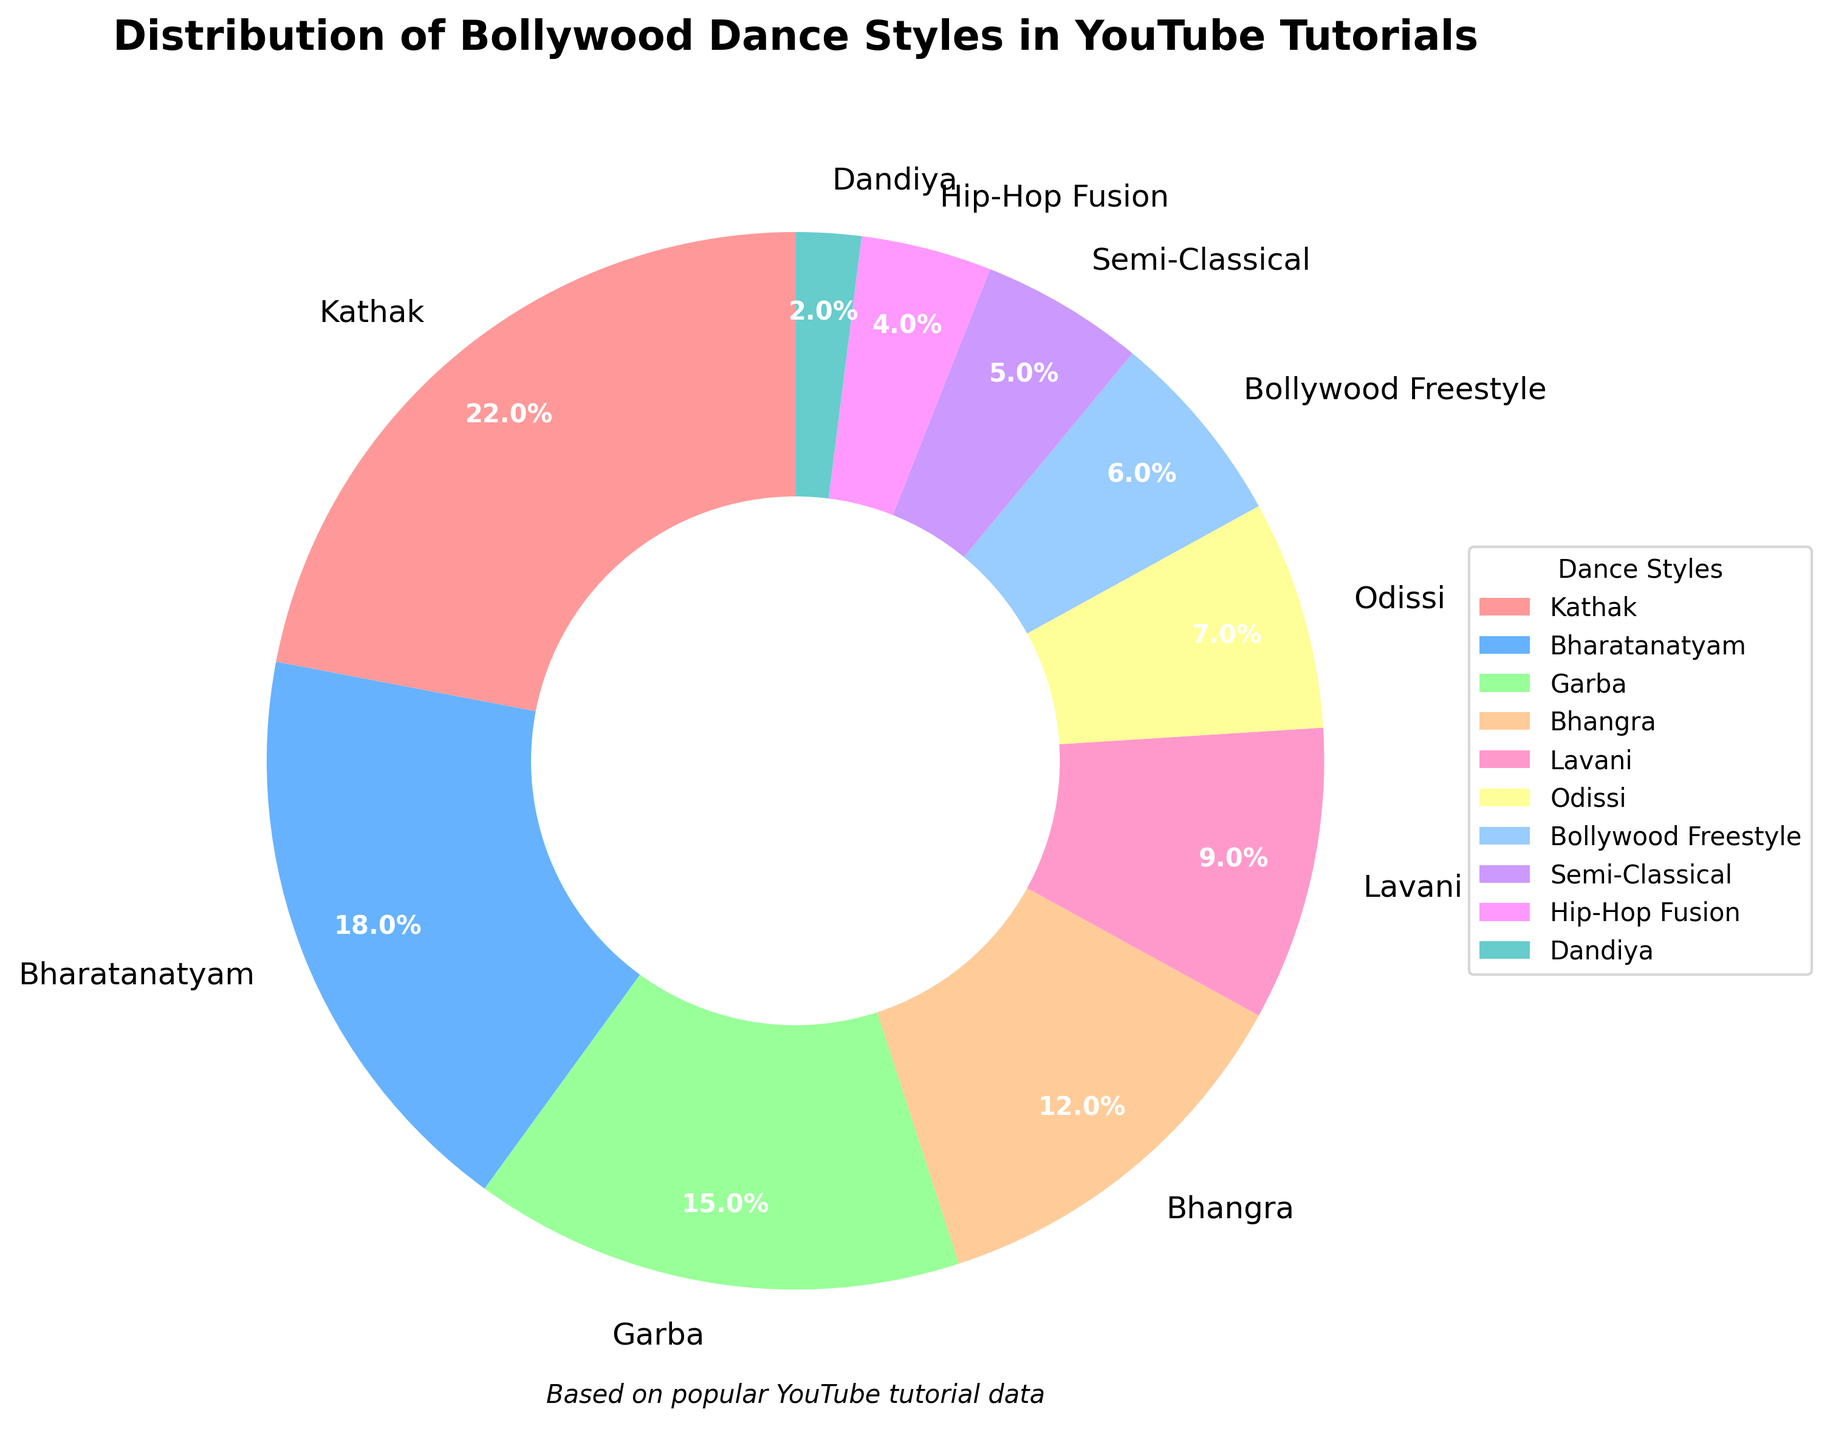What is the most popular dance style in the pie chart? The pie chart shows Kathak covering the largest segment. By looking at the visual size of the segments, Kathak is the largest.
Answer: Kathak Which dance styles contribute to exactly half of the distribution? We need to find styles summing up to 50%. Kathak (22%), Bharatanatyam (18%), and Garba (15%) exceed 50%. Checking smaller combinations, Kathak (22%), Bharatanatyam (18%), and Bhangra (12%) add up to 52%, so Kathak and Bharatanatyam alone sum to 40%. Adding Garba (15%), we exceed. Thus, no direct match of 50% is found for combinations.
Answer: None Which color represents the Lavani dance style in the pie chart? Each dance style is represented by a unique color. Lavani is colored similar to standard orange (second from bottom).
Answer: Orange How does the percentage of Bollywood Freestyle compare to Bhangra? Bollywood Freestyle is 6%, and Bhangra is 12%. Comparing these, Bhangra is larger.
Answer: Bhangra is larger What is the cumulative percentage of less popular styles (Hip-Hop Fusion, Semi-Classical, and Dandiya)? Sum the percentages of Hip-Hop Fusion (4%), Semi-Classical (5%), and Dandiya (2%). The sum is 4 + 5 + 2.
Answer: 11% What are the three least represented dance styles in the chart? Identify the smallest slices. Dandiya (2%), Hip-Hop Fusion (4%), and Semi-Classical (5%) are the smallest.
Answer: Dandiya, Hip-Hop Fusion, Semi-Classical Which two dance styles together make up more than one-third of the total distribution? Calculate combining two proportions to get more than 33.33%. Kathak (22%) and Bharatanatyam (18%) together make 40%.
Answer: Kathak and Bharatanatyam What is the difference in percentage between Garba and Odissi? Subtract the contribution of Odissi (7%) from Garba (15%). The difference is 15 - 7.
Answer: 8% If the total tutorials are 100, how many tutorials feature Lavani style? The percentage of Lavani is 9%. Out of 100 tutorials, 9% means 9 tutorials.
Answer: 9 tutorials Which dance style has a visual representation similar in color to blue? Scan for a color close to blue. Bharatanatyam seems to be a blue hue.
Answer: Bharatanatyam 